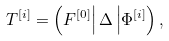Convert formula to latex. <formula><loc_0><loc_0><loc_500><loc_500>T ^ { [ i ] } = \left ( F ^ { [ 0 ] } \right | \Delta \left | \Phi ^ { [ i ] } \right ) ,</formula> 